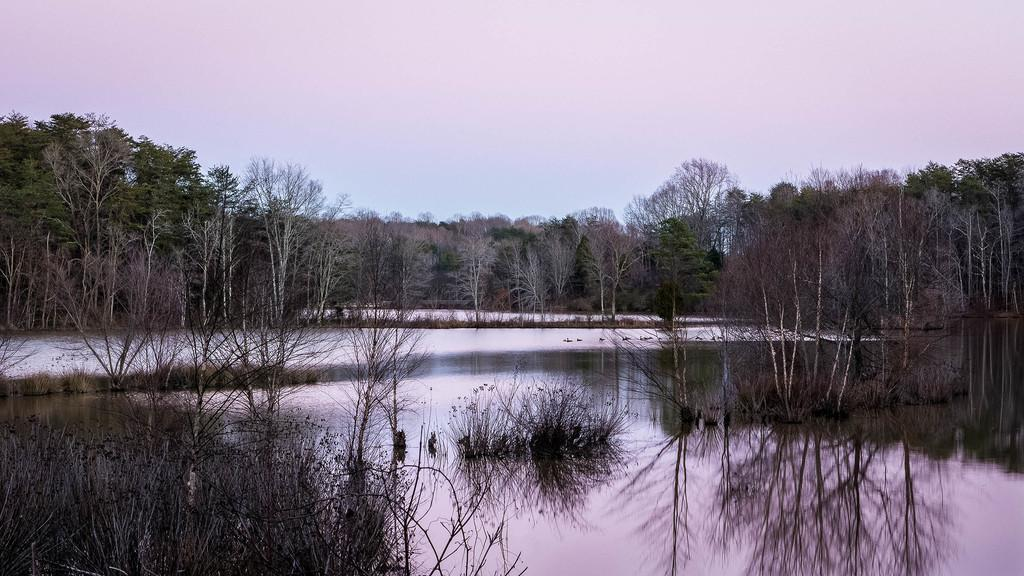What type of vegetation is present at the bottom of the picture? There are trees at the bottom of the picture. What is the body of water at the bottom of the picture? There is water at the bottom of the picture, possibly in a lake. What can be seen in the background of the image? There are trees in the background of the image. What is visible at the top of the image? The sky is visible at the top of the image. How much money is floating in the water at the bottom of the image? There is no money visible in the image; it features trees and water at the bottom. Can you tell me how many times the person in the image coughed? There is no person present in the image, so it is impossible to determine how many times they coughed. 